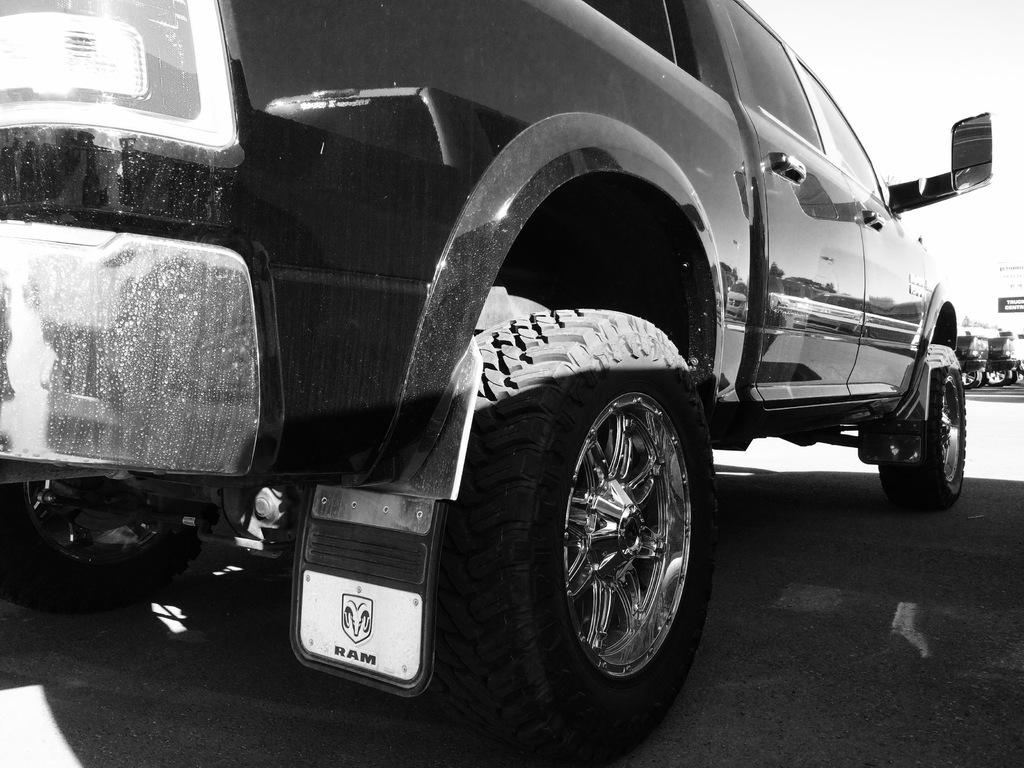What color is the car in the image? The car in the image is black. Where is the car located in the image? The car is on a road. What can be seen in the background of the image? There are many cars in the background of the image. What type of scent can be detected coming from the car in the image? There is no indication of a scent in the image, as it only shows a black car on a road with other cars in the background. 